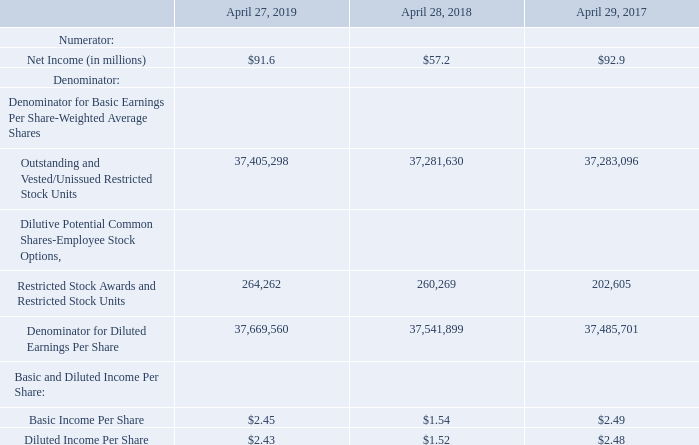8. Income Per Share
Basic income per share is calculated by dividing net earnings by the weighted average number of common shares outstanding for the applicable period. Diluted income per share is calculated after adjusting the denominator of the basic income per share calculation for the effect of all potential dilutive common shares outstanding during the period. The following table sets forth the computation of basic and diluted income per share:
For fiscal 2019, options and RSUs of 83,939 were excluded from the computation of diluted net income per share as their effect would have been anti-dilutive. For fiscal 2018 and fiscal 2017, the Company had no options or RSUs that were excluded from the computation of diluted net income per shares. RSAs for 594,382 shares in fiscal 2019, 363,413 shares in fiscal 2018 and 779,000 shares in fiscal 2017 were excluded from the calculation of diluted net income per share as these awards contain performance conditions that would not have been achieved as of the end of each reporting period had the measurement period ended as of that date.
How is basic income per share calculated? By dividing net earnings by the weighted average number of common shares outstanding for the applicable period. What amount of RSUs were excluded from the computation of diluted net income per share? 83,939. What were the RSAs in 2019, 2018 and 2017 respectively? 594,382, 363,413, 779,000. What was the change in the Net income from 2018 to 2019?
Answer scale should be: million. 91.6 - 57.2
Answer: 34.4. What is the average Outstanding and Vested/Unissued Restricted Stock Units for 2017-2019? (37,405,298 + 37,281,630 + 37,283,096) / 3
Answer: 37323341.33. In which year was Basic Income Per Share less than 2.0? Locate and analyze basic income per share in row 12
answer: 2018. 